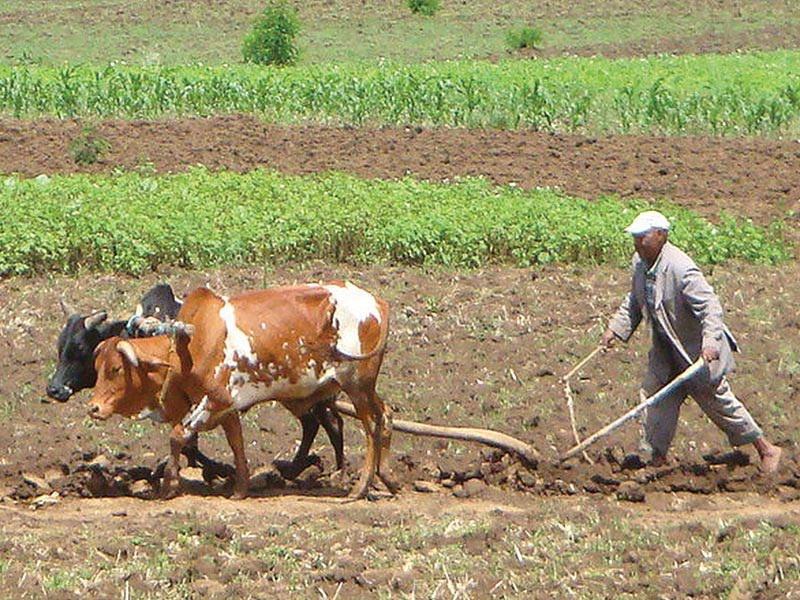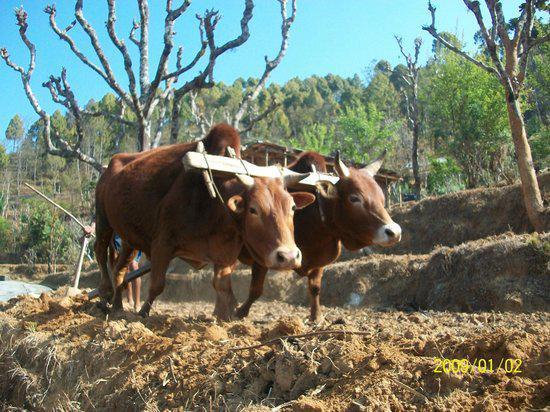The first image is the image on the left, the second image is the image on the right. Given the left and right images, does the statement "The humans are to the right of the cows in the left image." hold true? Answer yes or no. Yes. 